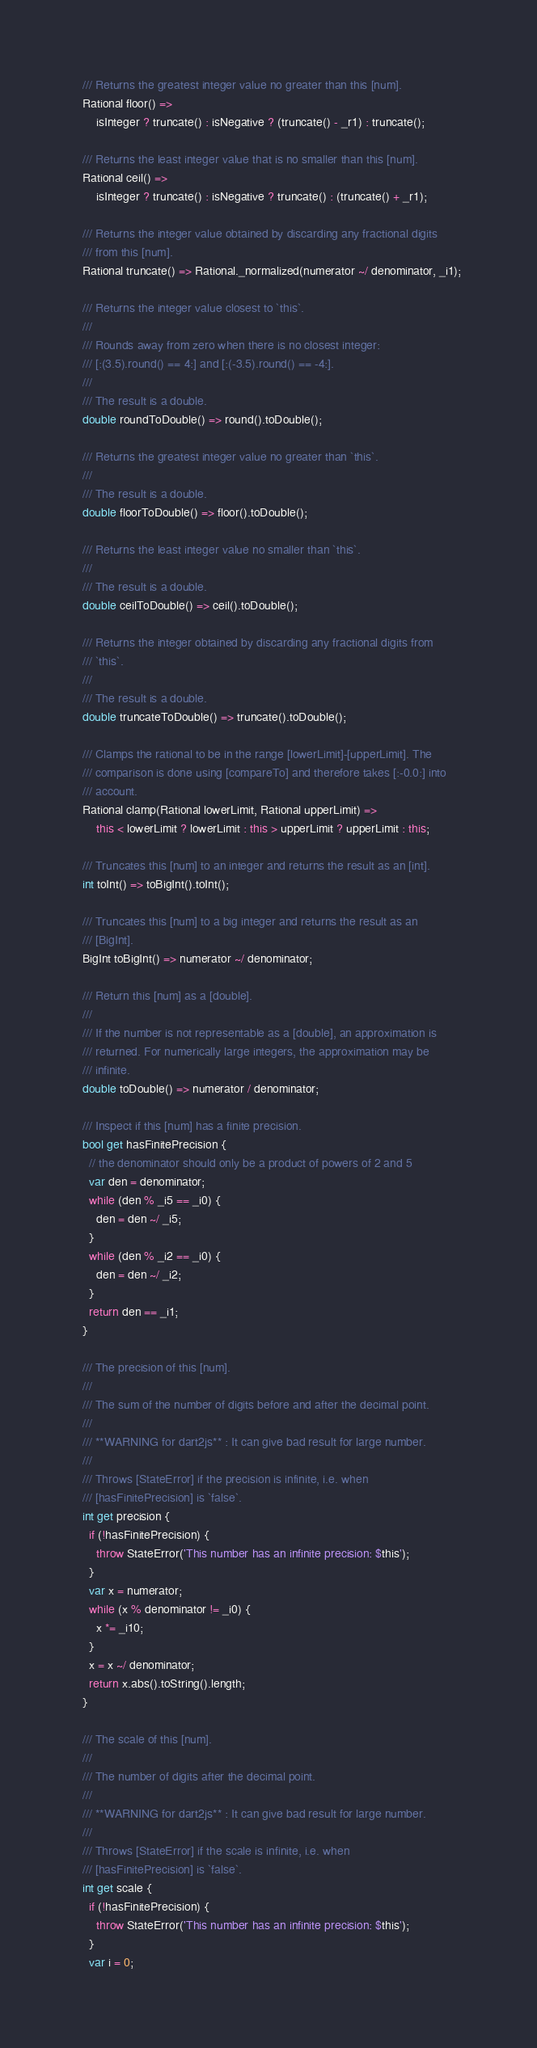<code> <loc_0><loc_0><loc_500><loc_500><_Dart_>
  /// Returns the greatest integer value no greater than this [num].
  Rational floor() =>
      isInteger ? truncate() : isNegative ? (truncate() - _r1) : truncate();

  /// Returns the least integer value that is no smaller than this [num].
  Rational ceil() =>
      isInteger ? truncate() : isNegative ? truncate() : (truncate() + _r1);

  /// Returns the integer value obtained by discarding any fractional digits
  /// from this [num].
  Rational truncate() => Rational._normalized(numerator ~/ denominator, _i1);

  /// Returns the integer value closest to `this`.
  ///
  /// Rounds away from zero when there is no closest integer:
  /// [:(3.5).round() == 4:] and [:(-3.5).round() == -4:].
  ///
  /// The result is a double.
  double roundToDouble() => round().toDouble();

  /// Returns the greatest integer value no greater than `this`.
  ///
  /// The result is a double.
  double floorToDouble() => floor().toDouble();

  /// Returns the least integer value no smaller than `this`.
  ///
  /// The result is a double.
  double ceilToDouble() => ceil().toDouble();

  /// Returns the integer obtained by discarding any fractional digits from
  /// `this`.
  ///
  /// The result is a double.
  double truncateToDouble() => truncate().toDouble();

  /// Clamps the rational to be in the range [lowerLimit]-[upperLimit]. The
  /// comparison is done using [compareTo] and therefore takes [:-0.0:] into
  /// account.
  Rational clamp(Rational lowerLimit, Rational upperLimit) =>
      this < lowerLimit ? lowerLimit : this > upperLimit ? upperLimit : this;

  /// Truncates this [num] to an integer and returns the result as an [int].
  int toInt() => toBigInt().toInt();

  /// Truncates this [num] to a big integer and returns the result as an
  /// [BigInt].
  BigInt toBigInt() => numerator ~/ denominator;

  /// Return this [num] as a [double].
  ///
  /// If the number is not representable as a [double], an approximation is
  /// returned. For numerically large integers, the approximation may be
  /// infinite.
  double toDouble() => numerator / denominator;

  /// Inspect if this [num] has a finite precision.
  bool get hasFinitePrecision {
    // the denominator should only be a product of powers of 2 and 5
    var den = denominator;
    while (den % _i5 == _i0) {
      den = den ~/ _i5;
    }
    while (den % _i2 == _i0) {
      den = den ~/ _i2;
    }
    return den == _i1;
  }

  /// The precision of this [num].
  ///
  /// The sum of the number of digits before and after the decimal point.
  ///
  /// **WARNING for dart2js** : It can give bad result for large number.
  ///
  /// Throws [StateError] if the precision is infinite, i.e. when
  /// [hasFinitePrecision] is `false`.
  int get precision {
    if (!hasFinitePrecision) {
      throw StateError('This number has an infinite precision: $this');
    }
    var x = numerator;
    while (x % denominator != _i0) {
      x *= _i10;
    }
    x = x ~/ denominator;
    return x.abs().toString().length;
  }

  /// The scale of this [num].
  ///
  /// The number of digits after the decimal point.
  ///
  /// **WARNING for dart2js** : It can give bad result for large number.
  ///
  /// Throws [StateError] if the scale is infinite, i.e. when
  /// [hasFinitePrecision] is `false`.
  int get scale {
    if (!hasFinitePrecision) {
      throw StateError('This number has an infinite precision: $this');
    }
    var i = 0;</code> 